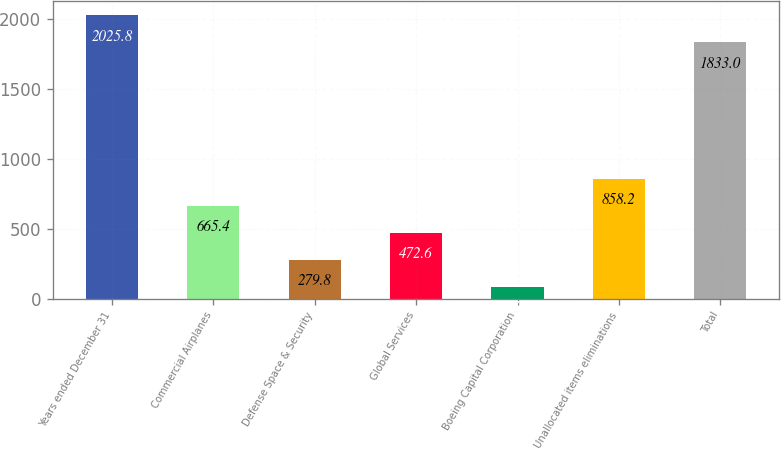Convert chart to OTSL. <chart><loc_0><loc_0><loc_500><loc_500><bar_chart><fcel>Years ended December 31<fcel>Commercial Airplanes<fcel>Defense Space & Security<fcel>Global Services<fcel>Boeing Capital Corporation<fcel>Unallocated items eliminations<fcel>Total<nl><fcel>2025.8<fcel>665.4<fcel>279.8<fcel>472.6<fcel>87<fcel>858.2<fcel>1833<nl></chart> 